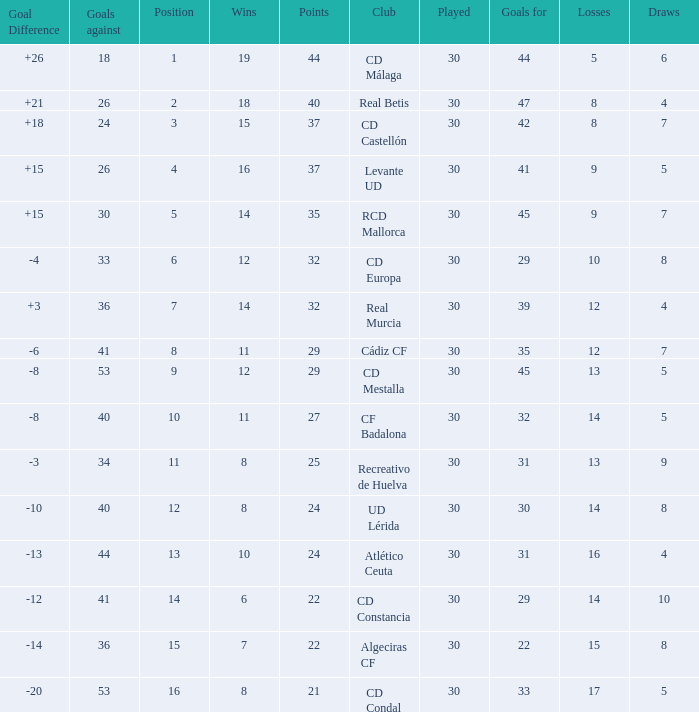What is the number of wins when the goals against is larger than 41, points is 29, and draws are larger than 5? 0.0. 